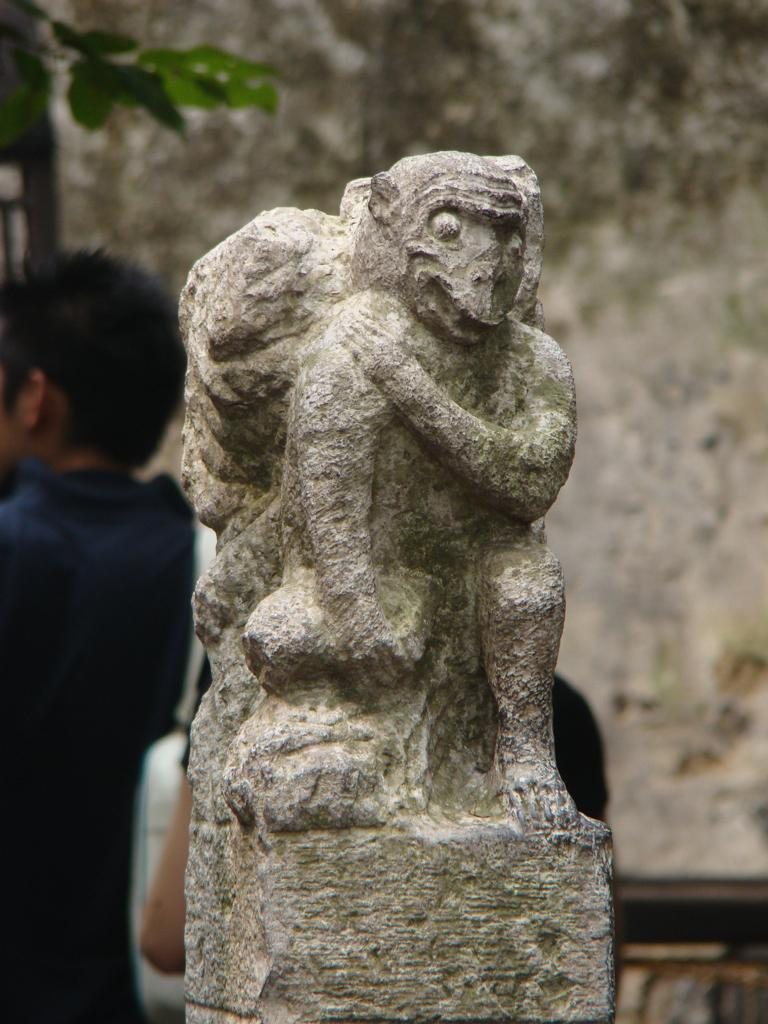What is the main subject in the image? There is a statue in the image. What can be seen in the background of the image? There are two persons, an object, leaves, and a wall in the background of the image. Can you tell me how many cans are floating in the ocean in the image? There is no ocean or can present in the image; it features a statue and elements in the background. 